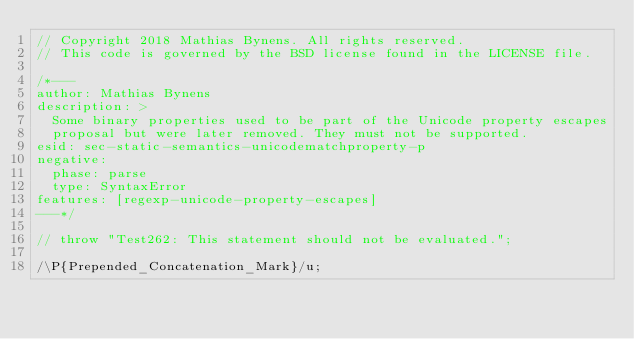Convert code to text. <code><loc_0><loc_0><loc_500><loc_500><_JavaScript_>// Copyright 2018 Mathias Bynens. All rights reserved.
// This code is governed by the BSD license found in the LICENSE file.

/*---
author: Mathias Bynens
description: >
  Some binary properties used to be part of the Unicode property escapes
  proposal but were later removed. They must not be supported.
esid: sec-static-semantics-unicodematchproperty-p
negative:
  phase: parse
  type: SyntaxError
features: [regexp-unicode-property-escapes]
---*/

// throw "Test262: This statement should not be evaluated.";

/\P{Prepended_Concatenation_Mark}/u;
</code> 